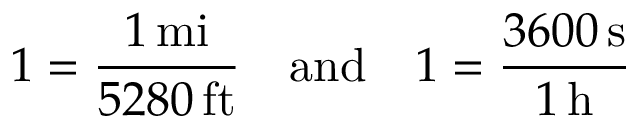<formula> <loc_0><loc_0><loc_500><loc_500>1 = { \frac { 1 \, m i } { 5 2 8 0 \, f t } } \quad a n d \quad 1 = { \frac { 3 6 0 0 \, s } { 1 \, h } }</formula> 